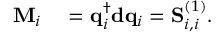<formula> <loc_0><loc_0><loc_500><loc_500>\begin{array} { r l } { M _ { i } } & = q _ { i } ^ { \dagger } d q _ { i } = S _ { i , i } ^ { ( 1 ) } . } \end{array}</formula> 